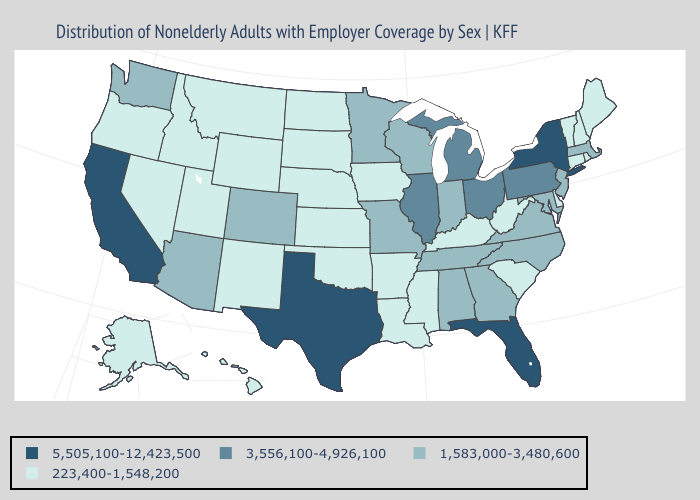Which states have the highest value in the USA?
Keep it brief. California, Florida, New York, Texas. Name the states that have a value in the range 5,505,100-12,423,500?
Be succinct. California, Florida, New York, Texas. What is the lowest value in the MidWest?
Write a very short answer. 223,400-1,548,200. Which states have the lowest value in the Northeast?
Concise answer only. Connecticut, Maine, New Hampshire, Rhode Island, Vermont. What is the highest value in states that border Illinois?
Be succinct. 1,583,000-3,480,600. Does Pennsylvania have the same value as Missouri?
Keep it brief. No. How many symbols are there in the legend?
Be succinct. 4. What is the highest value in the USA?
Quick response, please. 5,505,100-12,423,500. Among the states that border New Mexico , which have the lowest value?
Give a very brief answer. Oklahoma, Utah. What is the highest value in the West ?
Give a very brief answer. 5,505,100-12,423,500. How many symbols are there in the legend?
Quick response, please. 4. Does Ohio have the highest value in the USA?
Keep it brief. No. What is the value of Montana?
Answer briefly. 223,400-1,548,200. What is the highest value in states that border Iowa?
Write a very short answer. 3,556,100-4,926,100. Does Florida have the highest value in the South?
Short answer required. Yes. 